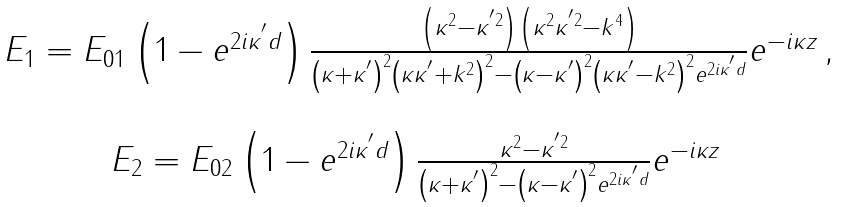<formula> <loc_0><loc_0><loc_500><loc_500>\begin{array} { c } E _ { 1 } = E _ { 0 1 } \left ( 1 - e ^ { 2 i \kappa ^ { ^ { \prime } } d } \right ) \frac { \left ( \kappa ^ { 2 } - \kappa ^ { ^ { \prime } 2 } \right ) \left ( \kappa ^ { 2 } \kappa ^ { ^ { \prime } 2 } - k ^ { 4 } \right ) } { \left ( \kappa + \kappa ^ { ^ { \prime } } \right ) ^ { 2 } \left ( \kappa \kappa ^ { ^ { \prime } } + k ^ { 2 } \right ) ^ { 2 } - \left ( \kappa - \kappa ^ { ^ { \prime } } \right ) ^ { 2 } \left ( \kappa \kappa ^ { ^ { \prime } } - k ^ { 2 } \right ) ^ { 2 } e ^ { 2 i \kappa ^ { ^ { \prime } } d } } e ^ { - i \kappa z } \, , \\ \\ E _ { 2 } = E _ { 0 2 } \left ( 1 - e ^ { 2 i \kappa ^ { ^ { \prime } } d } \right ) \frac { \kappa ^ { 2 } - \kappa ^ { ^ { \prime } 2 } } { \left ( \kappa + \kappa ^ { ^ { \prime } } \right ) ^ { 2 } - \left ( \kappa - \kappa ^ { ^ { \prime } } \right ) ^ { 2 } e ^ { 2 i \kappa ^ { ^ { \prime } } d } } e ^ { - i \kappa z } \, \end{array}</formula> 